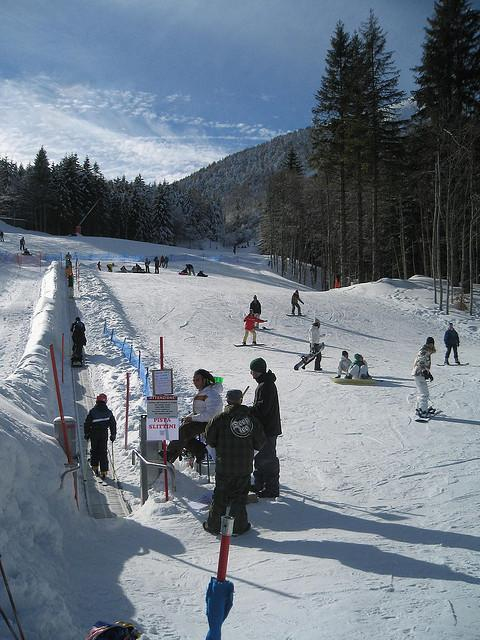What level of skier is this part of the hill designed for? Please explain your reasoning. beginner. This is a small hill with a minimal slope, it is easy to maneuver and is a good environment to learn and develop ability without high risk. you can also see several children present who are generally just starting to learn. 